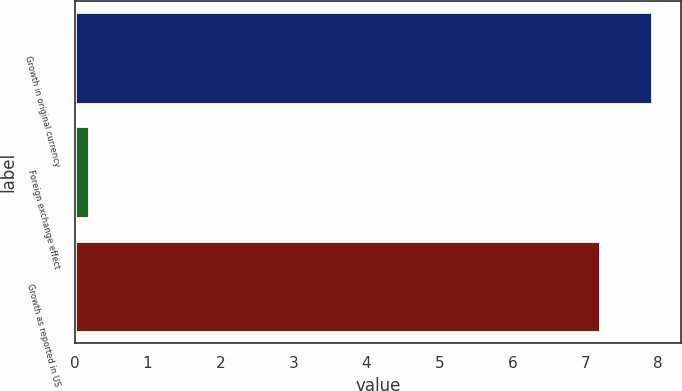Convert chart to OTSL. <chart><loc_0><loc_0><loc_500><loc_500><bar_chart><fcel>Growth in original currency<fcel>Foreign exchange effect<fcel>Growth as reported in US<nl><fcel>7.92<fcel>0.2<fcel>7.2<nl></chart> 